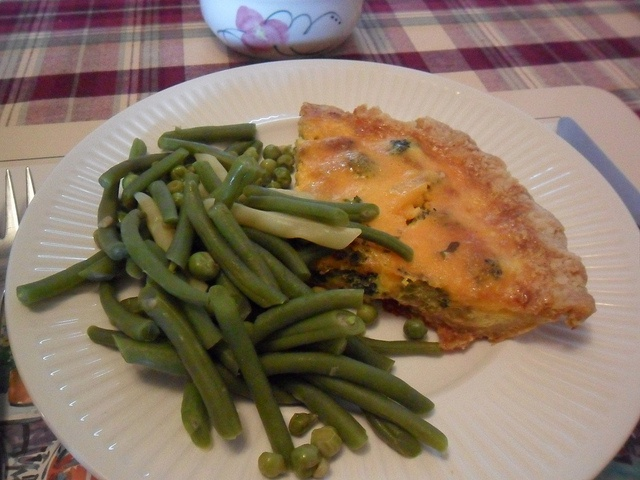Describe the objects in this image and their specific colors. I can see dining table in gray, darkgray, and purple tones, bowl in gray, darkgray, and lightblue tones, and fork in gray, ivory, darkgray, and lightgray tones in this image. 